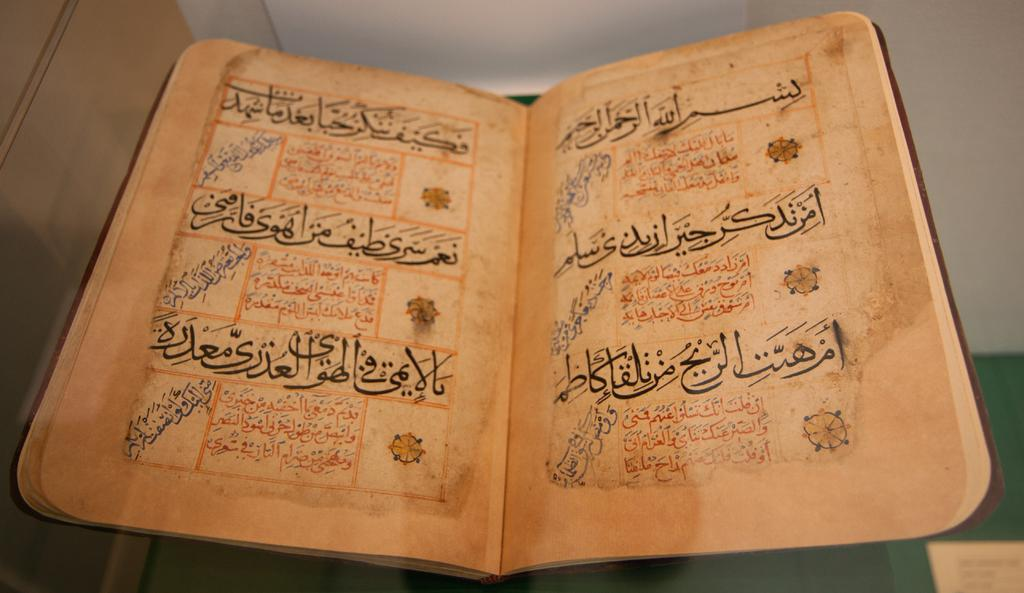<image>
Provide a brief description of the given image. a book has many letters on it of a different language 